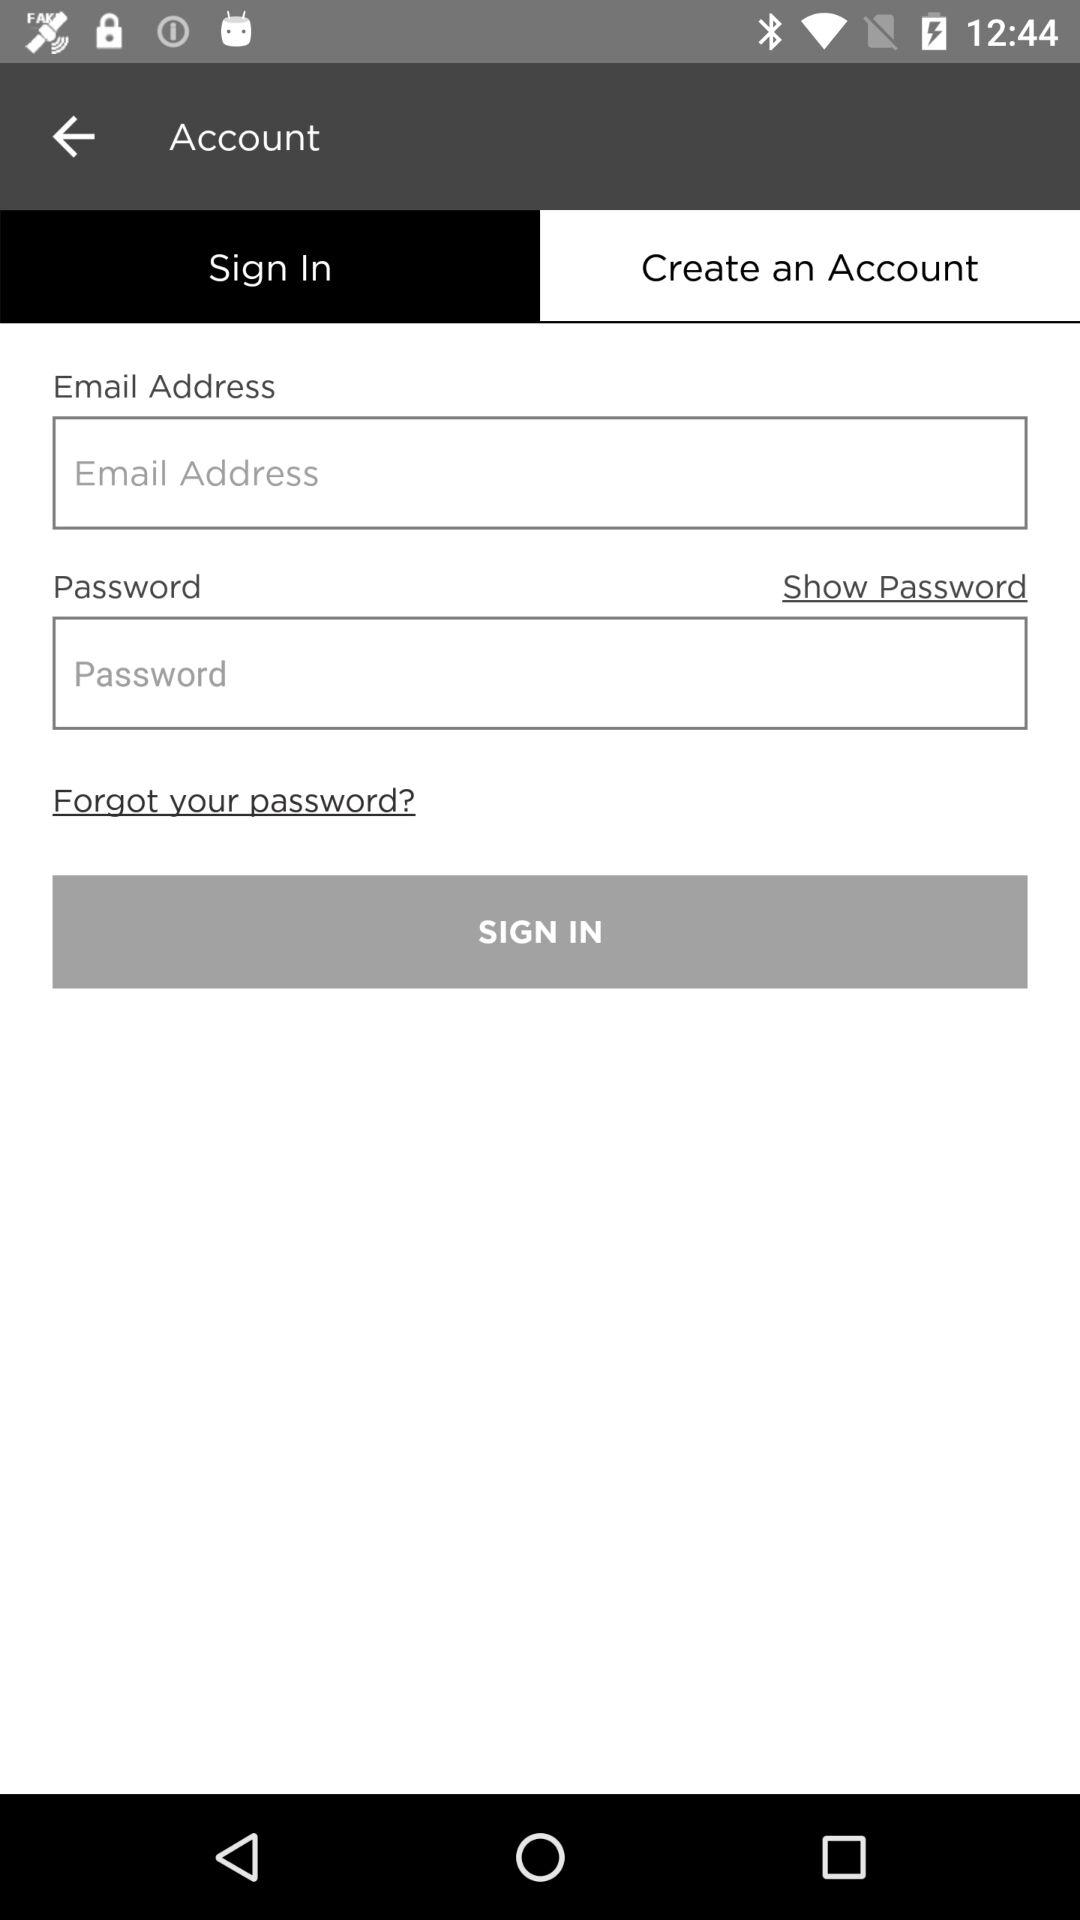Which tab is selected? The selected tab is "Sign In". 